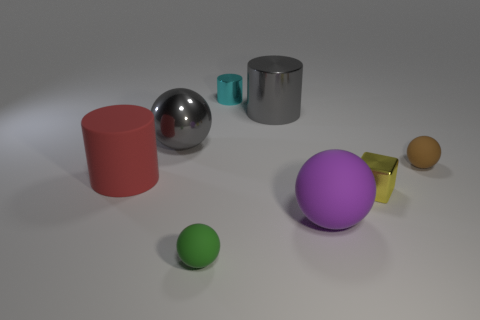How many other objects are there of the same material as the big gray cylinder?
Keep it short and to the point. 3. There is a ball that is behind the large purple rubber ball and in front of the large metal ball; what size is it?
Give a very brief answer. Small. What shape is the tiny thing that is in front of the big matte thing in front of the yellow metal object?
Give a very brief answer. Sphere. Is there any other thing that has the same shape as the red matte object?
Your answer should be very brief. Yes. Are there the same number of big shiny balls that are in front of the yellow shiny cube and yellow blocks?
Your answer should be very brief. No. There is a large shiny cylinder; does it have the same color as the sphere that is to the right of the tiny yellow cube?
Provide a short and direct response. No. What is the color of the small object that is left of the big shiny cylinder and in front of the big metallic cylinder?
Offer a terse response. Green. There is a small shiny object that is left of the big purple rubber ball; how many small cyan metal cylinders are to the right of it?
Ensure brevity in your answer.  0. Are there any small cyan objects that have the same shape as the red matte object?
Keep it short and to the point. Yes. There is a tiny rubber object that is in front of the small brown object; is it the same shape as the large rubber thing in front of the big red cylinder?
Your answer should be compact. Yes. 